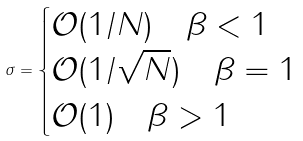Convert formula to latex. <formula><loc_0><loc_0><loc_500><loc_500>\sigma = \begin{cases} \mathcal { O } ( 1 / N ) \quad \beta < 1 \\ \mathcal { O } ( 1 / \sqrt { N } ) \quad \beta = 1 \\ \mathcal { O } ( 1 ) \quad \beta > 1 \end{cases}</formula> 